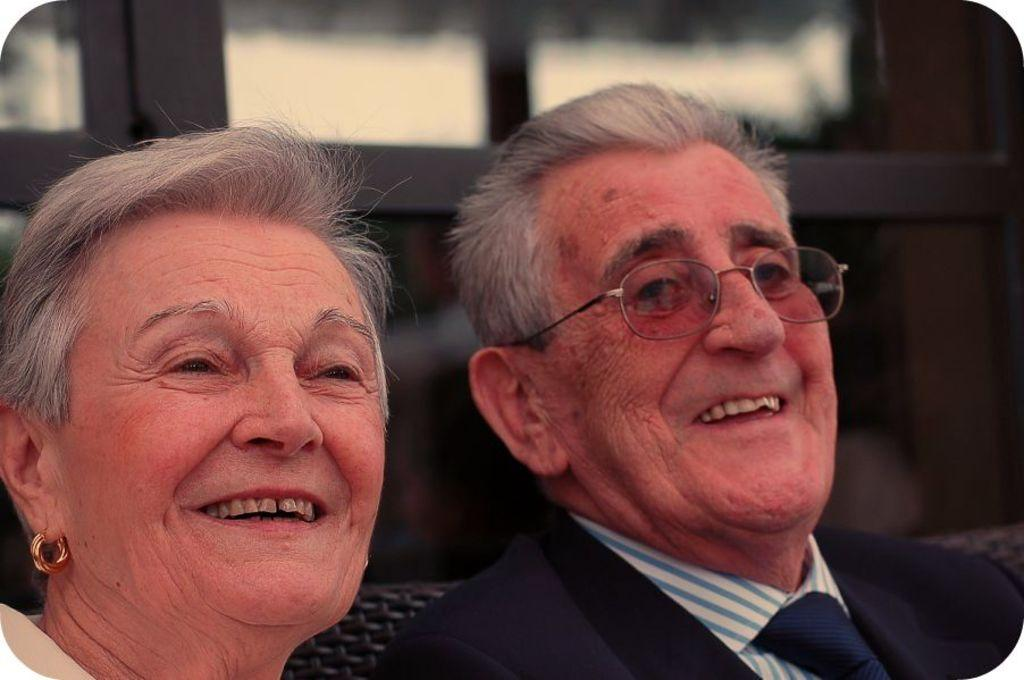How many people are in the image? There are two persons in the image. What is the person on the right wearing? The person on the right is wearing a blue blazer and a white shirt. What can be seen in the background of the image? There are glass windows in the background of the image. What type of vegetable is the person on the left holding in the image? There is no vegetable present in the image, and the person on the left is not holding anything. What are the hobbies of the person on the right? The facts provided do not mention the hobbies of the person on the right, so we cannot determine their hobbies from the image. 